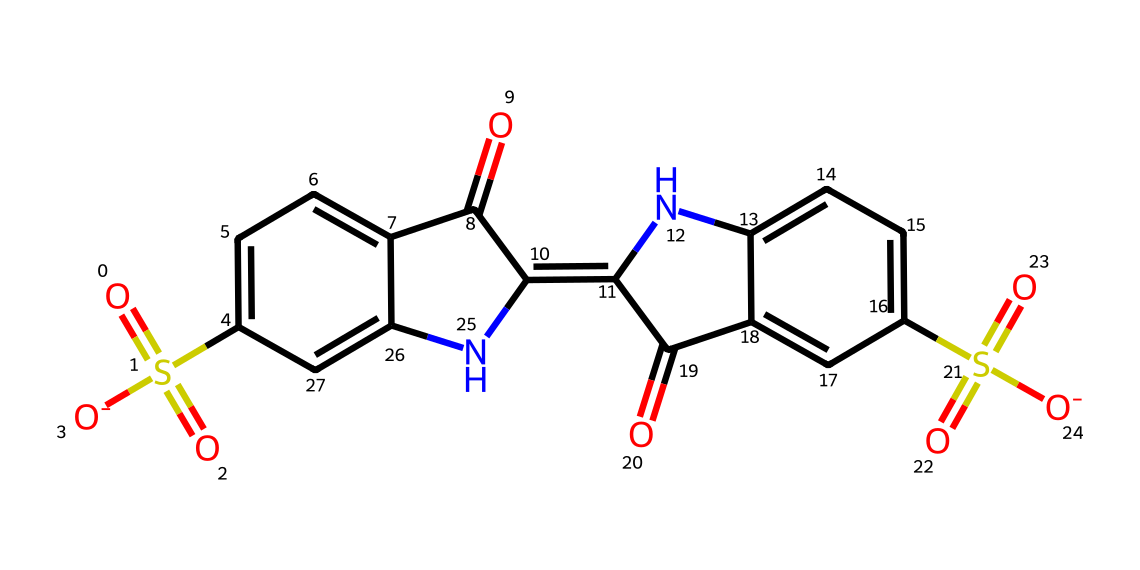What is the molecular formula of indigo carmine? Looking at the structural representation, we can determine the composition of atoms in the dye. Counting the carbon (C), hydrogen (H), nitrogen (N), oxygen (O), and sulfur (S) atoms gives us the molecular formula C16H8N2Na2O8S2.
Answer: C16H8N2Na2O8S2 How many nitrogen atoms are present in indigo carmine? By examining the structure, there are two distinct nitrogen atoms indicated by the presence of N in the chemical formula.
Answer: 2 What is the primary use of indigo carmine? Indigo carmine is widely utilized in medical tests and food coloring. Thus, its primary application pertains to these sectors.
Answer: medical tests and food coloring Which part of this dye contributes to its blue color? The conjugated system consisting of alternating double bonds across the π-electrons allows the absorption of specific wavelengths of light, resulting in the blue color.
Answer: conjugated system Does indigo carmine contain any functional groups? Yes, the structure contains sulfonate (-SO3), carbonyl (C=O), and amine (-NH) functional groups, which are important for its properties and reactivity.
Answer: Yes In what form is indigo carmine commonly found? Indigocarmine is typically found in a sodium salt form that facilitates its solubility in water, a crucial aspect for its application in tests and as a dye.
Answer: sodium salt How many rings are present in the indigo carmine structure? Upon analyzing the chemical structure, there are two fused aromatic rings in the indigo carmine molecule, making it a polycyclic compound.
Answer: 2 